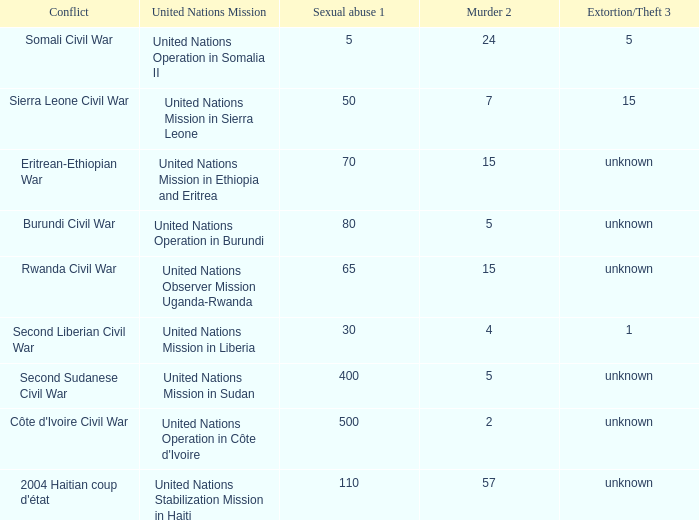What is the extortion and theft rates where the United Nations Observer Mission Uganda-Rwanda is active? Unknown. 